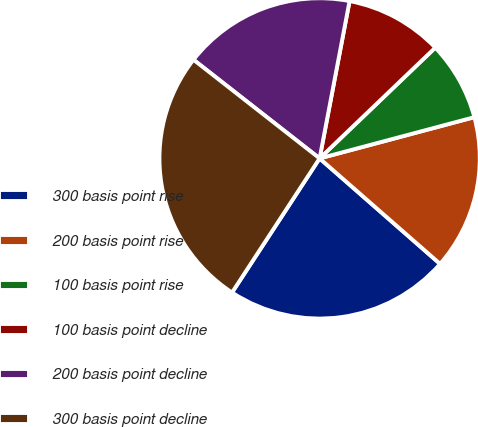<chart> <loc_0><loc_0><loc_500><loc_500><pie_chart><fcel>300 basis point rise<fcel>200 basis point rise<fcel>100 basis point rise<fcel>100 basis point decline<fcel>200 basis point decline<fcel>300 basis point decline<nl><fcel>22.76%<fcel>15.59%<fcel>8.01%<fcel>9.85%<fcel>17.43%<fcel>26.36%<nl></chart> 